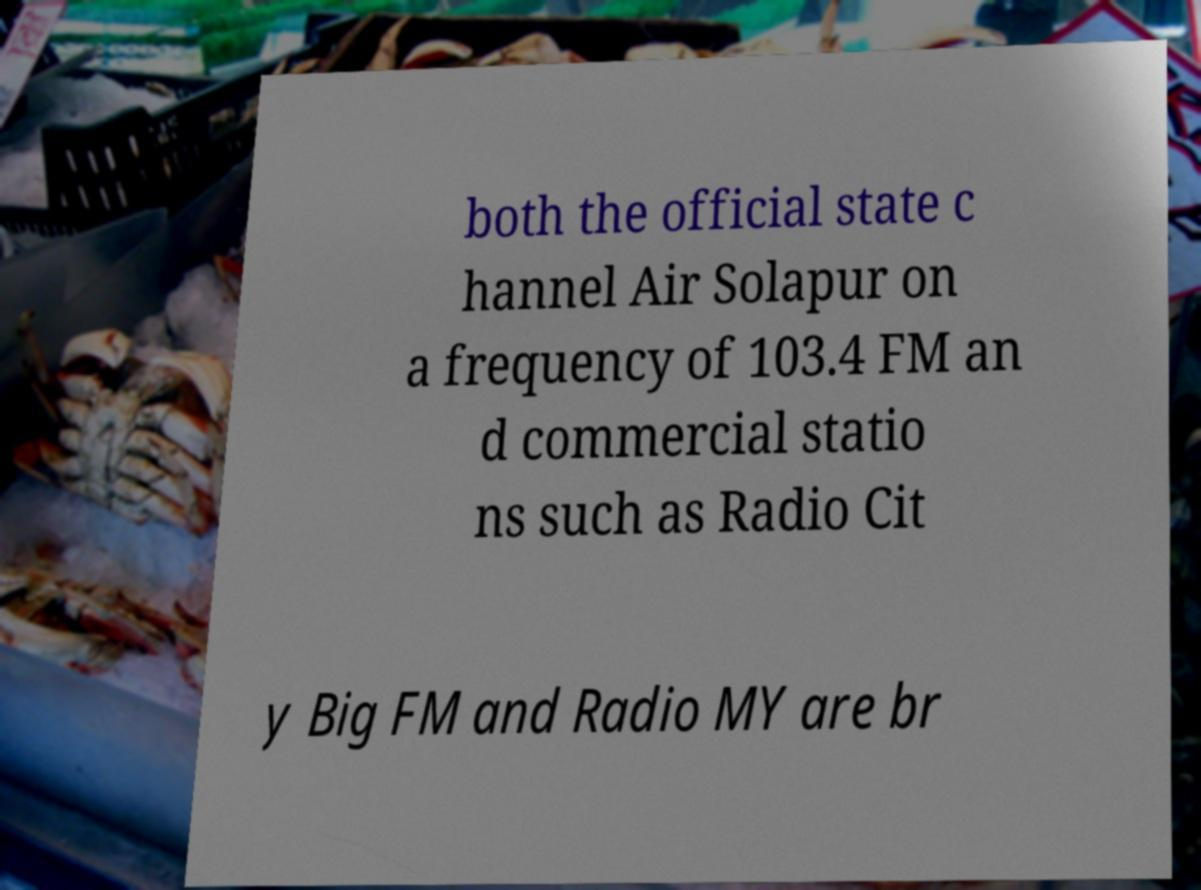Can you accurately transcribe the text from the provided image for me? both the official state c hannel Air Solapur on a frequency of 103.4 FM an d commercial statio ns such as Radio Cit y Big FM and Radio MY are br 